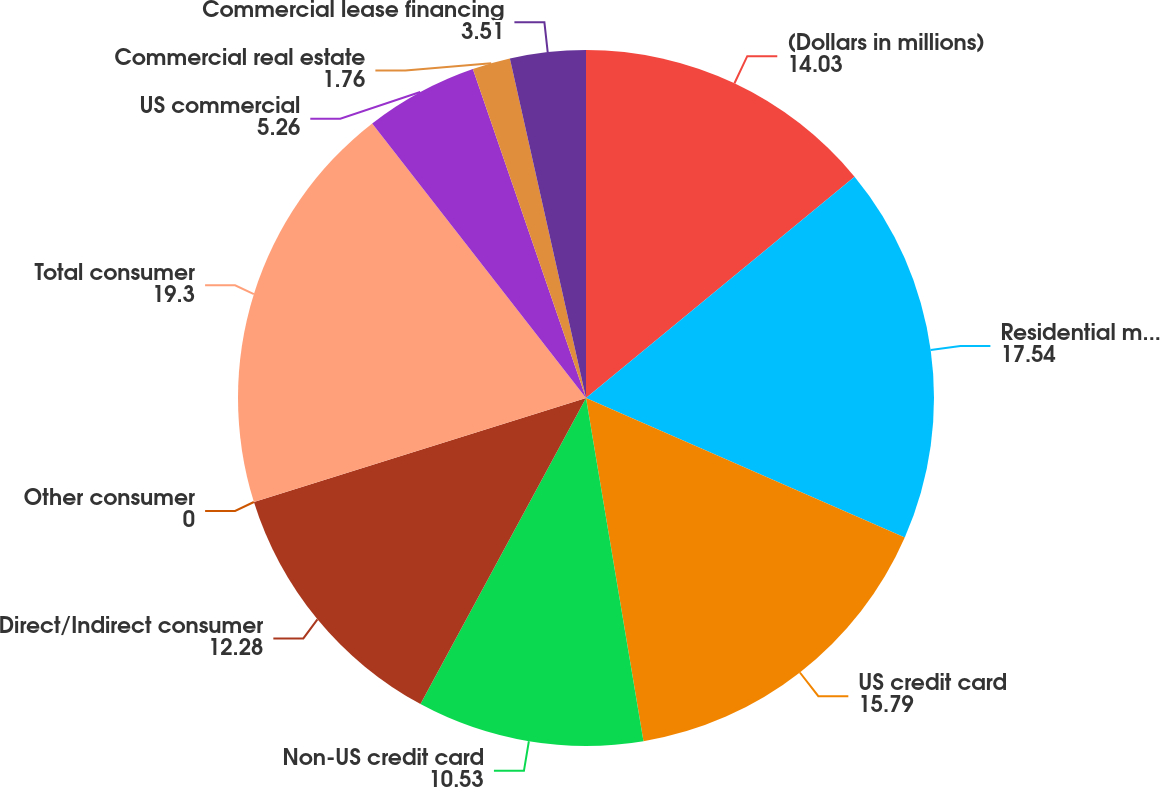Convert chart to OTSL. <chart><loc_0><loc_0><loc_500><loc_500><pie_chart><fcel>(Dollars in millions)<fcel>Residential mortgage (2)<fcel>US credit card<fcel>Non-US credit card<fcel>Direct/Indirect consumer<fcel>Other consumer<fcel>Total consumer<fcel>US commercial<fcel>Commercial real estate<fcel>Commercial lease financing<nl><fcel>14.03%<fcel>17.54%<fcel>15.79%<fcel>10.53%<fcel>12.28%<fcel>0.0%<fcel>19.3%<fcel>5.26%<fcel>1.76%<fcel>3.51%<nl></chart> 